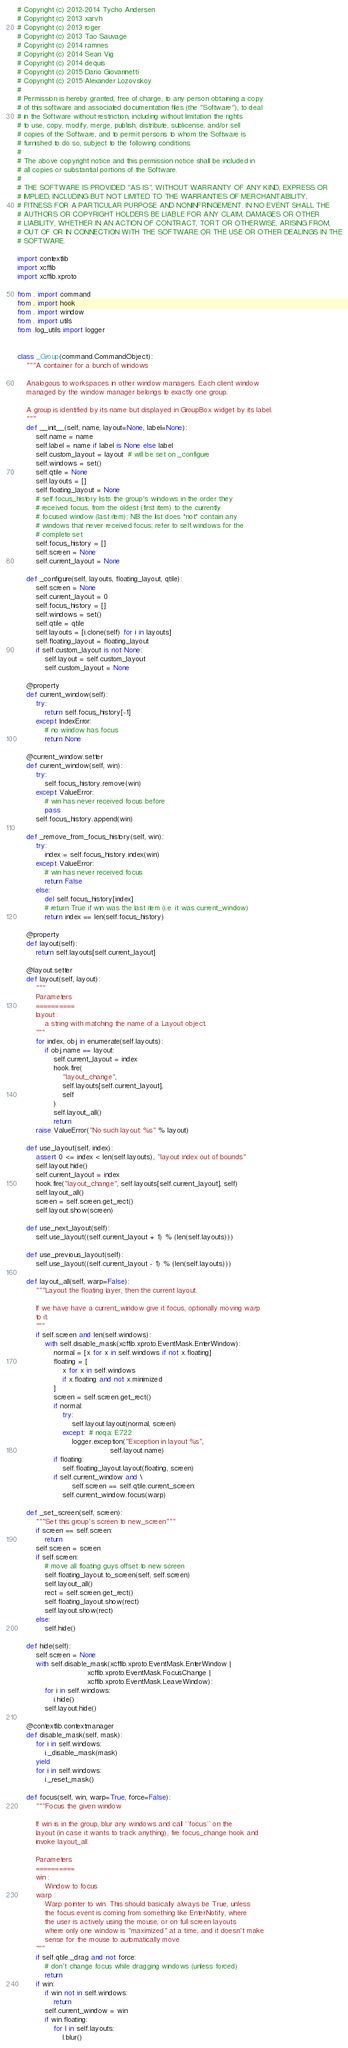Convert code to text. <code><loc_0><loc_0><loc_500><loc_500><_Python_># Copyright (c) 2012-2014 Tycho Andersen
# Copyright (c) 2013 xarvh
# Copyright (c) 2013 roger
# Copyright (c) 2013 Tao Sauvage
# Copyright (c) 2014 ramnes
# Copyright (c) 2014 Sean Vig
# Copyright (c) 2014 dequis
# Copyright (c) 2015 Dario Giovannetti
# Copyright (c) 2015 Alexander Lozovskoy
#
# Permission is hereby granted, free of charge, to any person obtaining a copy
# of this software and associated documentation files (the "Software"), to deal
# in the Software without restriction, including without limitation the rights
# to use, copy, modify, merge, publish, distribute, sublicense, and/or sell
# copies of the Software, and to permit persons to whom the Software is
# furnished to do so, subject to the following conditions:
#
# The above copyright notice and this permission notice shall be included in
# all copies or substantial portions of the Software.
#
# THE SOFTWARE IS PROVIDED "AS IS", WITHOUT WARRANTY OF ANY KIND, EXPRESS OR
# IMPLIED, INCLUDING BUT NOT LIMITED TO THE WARRANTIES OF MERCHANTABILITY,
# FITNESS FOR A PARTICULAR PURPOSE AND NONINFRINGEMENT. IN NO EVENT SHALL THE
# AUTHORS OR COPYRIGHT HOLDERS BE LIABLE FOR ANY CLAIM, DAMAGES OR OTHER
# LIABILITY, WHETHER IN AN ACTION OF CONTRACT, TORT OR OTHERWISE, ARISING FROM,
# OUT OF OR IN CONNECTION WITH THE SOFTWARE OR THE USE OR OTHER DEALINGS IN THE
# SOFTWARE.

import contextlib
import xcffib
import xcffib.xproto

from . import command
from . import hook
from . import window
from . import utils
from .log_utils import logger


class _Group(command.CommandObject):
    """A container for a bunch of windows

    Analogous to workspaces in other window managers. Each client window
    managed by the window manager belongs to exactly one group.

    A group is identified by its name but displayed in GroupBox widget by its label.
    """
    def __init__(self, name, layout=None, label=None):
        self.name = name
        self.label = name if label is None else label
        self.custom_layout = layout  # will be set on _configure
        self.windows = set()
        self.qtile = None
        self.layouts = []
        self.floating_layout = None
        # self.focus_history lists the group's windows in the order they
        # received focus, from the oldest (first item) to the currently
        # focused window (last item); NB the list does *not* contain any
        # windows that never received focus; refer to self.windows for the
        # complete set
        self.focus_history = []
        self.screen = None
        self.current_layout = None

    def _configure(self, layouts, floating_layout, qtile):
        self.screen = None
        self.current_layout = 0
        self.focus_history = []
        self.windows = set()
        self.qtile = qtile
        self.layouts = [i.clone(self) for i in layouts]
        self.floating_layout = floating_layout
        if self.custom_layout is not None:
            self.layout = self.custom_layout
            self.custom_layout = None

    @property
    def current_window(self):
        try:
            return self.focus_history[-1]
        except IndexError:
            # no window has focus
            return None

    @current_window.setter
    def current_window(self, win):
        try:
            self.focus_history.remove(win)
        except ValueError:
            # win has never received focus before
            pass
        self.focus_history.append(win)

    def _remove_from_focus_history(self, win):
        try:
            index = self.focus_history.index(win)
        except ValueError:
            # win has never received focus
            return False
        else:
            del self.focus_history[index]
            # return True if win was the last item (i.e. it was current_window)
            return index == len(self.focus_history)

    @property
    def layout(self):
        return self.layouts[self.current_layout]

    @layout.setter
    def layout(self, layout):
        """
        Parameters
        ==========
        layout :
            a string with matching the name of a Layout object.
        """
        for index, obj in enumerate(self.layouts):
            if obj.name == layout:
                self.current_layout = index
                hook.fire(
                    "layout_change",
                    self.layouts[self.current_layout],
                    self
                )
                self.layout_all()
                return
        raise ValueError("No such layout: %s" % layout)

    def use_layout(self, index):
        assert 0 <= index < len(self.layouts), "layout index out of bounds"
        self.layout.hide()
        self.current_layout = index
        hook.fire("layout_change", self.layouts[self.current_layout], self)
        self.layout_all()
        screen = self.screen.get_rect()
        self.layout.show(screen)

    def use_next_layout(self):
        self.use_layout((self.current_layout + 1) % (len(self.layouts)))

    def use_previous_layout(self):
        self.use_layout((self.current_layout - 1) % (len(self.layouts)))

    def layout_all(self, warp=False):
        """Layout the floating layer, then the current layout.

        If we have have a current_window give it focus, optionally moving warp
        to it.
        """
        if self.screen and len(self.windows):
            with self.disable_mask(xcffib.xproto.EventMask.EnterWindow):
                normal = [x for x in self.windows if not x.floating]
                floating = [
                    x for x in self.windows
                    if x.floating and not x.minimized
                ]
                screen = self.screen.get_rect()
                if normal:
                    try:
                        self.layout.layout(normal, screen)
                    except:  # noqa: E722
                        logger.exception("Exception in layout %s",
                                         self.layout.name)
                if floating:
                    self.floating_layout.layout(floating, screen)
                if self.current_window and \
                        self.screen == self.qtile.current_screen:
                    self.current_window.focus(warp)

    def _set_screen(self, screen):
        """Set this group's screen to new_screen"""
        if screen == self.screen:
            return
        self.screen = screen
        if self.screen:
            # move all floating guys offset to new screen
            self.floating_layout.to_screen(self, self.screen)
            self.layout_all()
            rect = self.screen.get_rect()
            self.floating_layout.show(rect)
            self.layout.show(rect)
        else:
            self.hide()

    def hide(self):
        self.screen = None
        with self.disable_mask(xcffib.xproto.EventMask.EnterWindow |
                               xcffib.xproto.EventMask.FocusChange |
                               xcffib.xproto.EventMask.LeaveWindow):
            for i in self.windows:
                i.hide()
            self.layout.hide()

    @contextlib.contextmanager
    def disable_mask(self, mask):
        for i in self.windows:
            i._disable_mask(mask)
        yield
        for i in self.windows:
            i._reset_mask()

    def focus(self, win, warp=True, force=False):
        """Focus the given window

        If win is in the group, blur any windows and call ``focus`` on the
        layout (in case it wants to track anything), fire focus_change hook and
        invoke layout_all.

        Parameters
        ==========
        win :
            Window to focus
        warp :
            Warp pointer to win. This should basically always be True, unless
            the focus event is coming from something like EnterNotify, where
            the user is actively using the mouse, or on full screen layouts
            where only one window is "maximized" at a time, and it doesn't make
            sense for the mouse to automatically move.
        """
        if self.qtile._drag and not force:
            # don't change focus while dragging windows (unless forced)
            return
        if win:
            if win not in self.windows:
                return
            self.current_window = win
            if win.floating:
                for l in self.layouts:
                    l.blur()</code> 